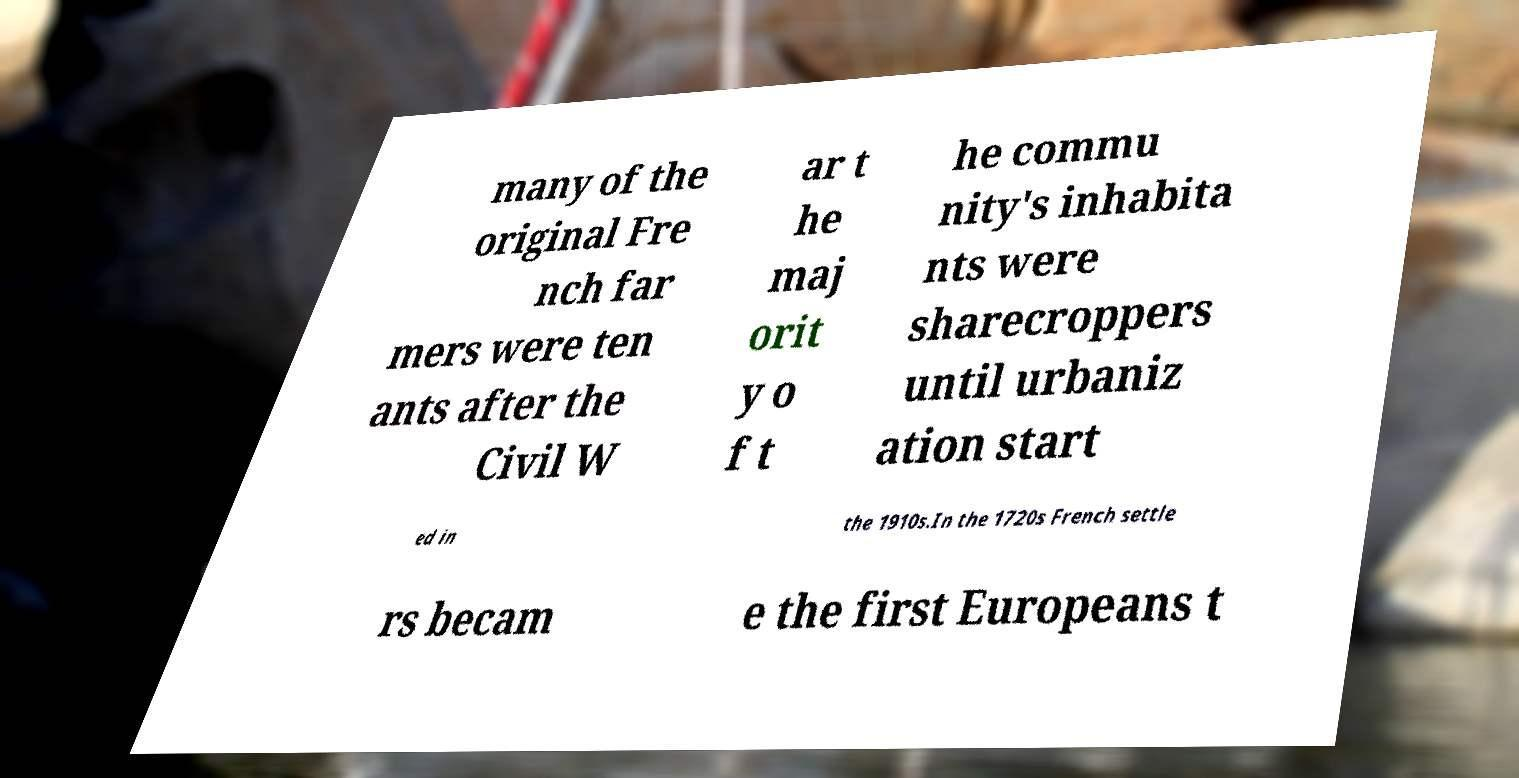Could you assist in decoding the text presented in this image and type it out clearly? many of the original Fre nch far mers were ten ants after the Civil W ar t he maj orit y o f t he commu nity's inhabita nts were sharecroppers until urbaniz ation start ed in the 1910s.In the 1720s French settle rs becam e the first Europeans t 